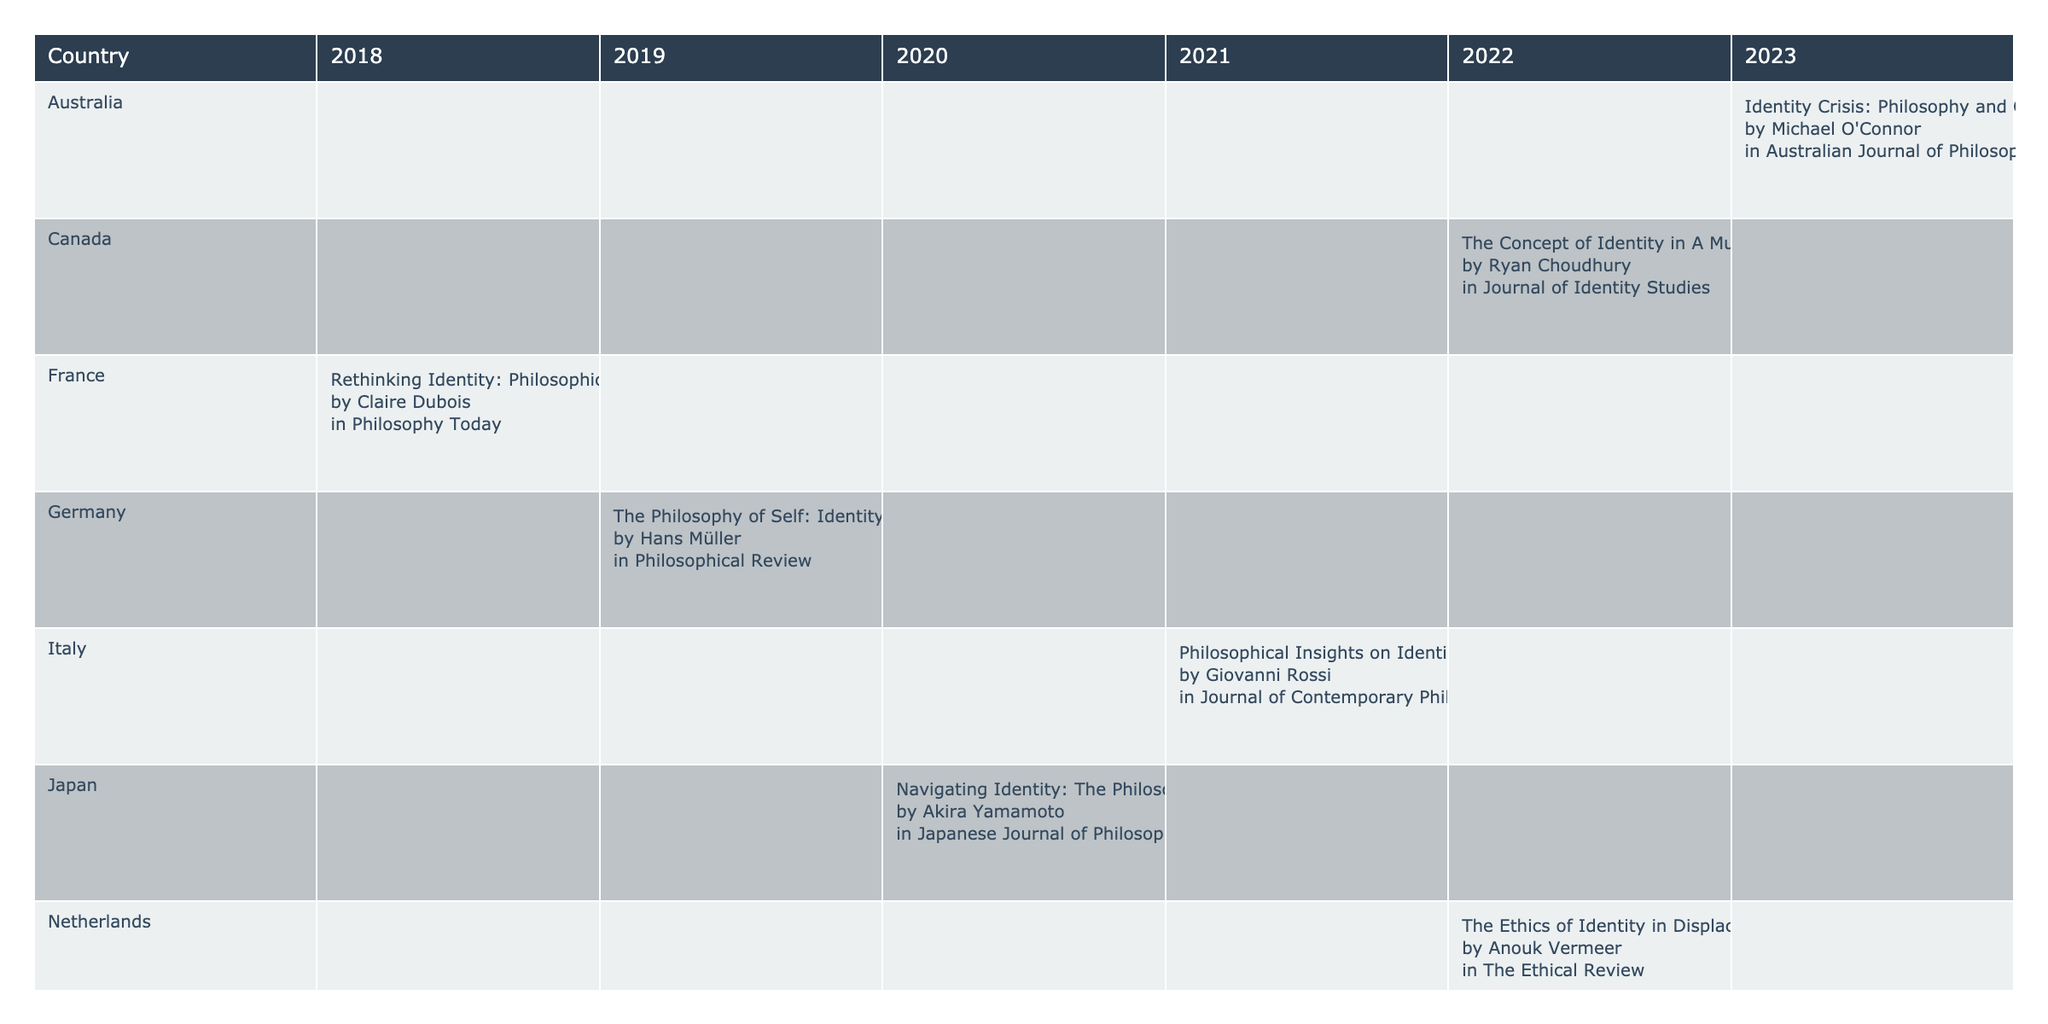What is the title of the publication from Germany? Looking at the row for Germany, the publication title for the year 2019 is "The Philosophy of Self: Identity in the Age of Migration".
Answer: The Philosophy of Self: Identity in the Age of Migration How many publications are listed for the year 2022? By counting the entries in the year 2022, there are two publications: one from Canada and one from the Netherlands.
Answer: 2 Is there a publication from South Africa in 2020? Checking the table, South Africa has a publication listed in 2019, but there is no entry for the year 2020.
Answer: No Which country had the earliest publication related to identity and displacement? The earliest year in the table is 2018, and the only entry is from France with the title "Rethinking Identity: Philosophical Approaches to Displacement".
Answer: France What is the average number of publications per year based on the data provided? There are a total of 10 publications across the years 2018 to 2023 (6 years). The average is thus 10 publications divided by 6 years, which equals approximately 1.67.
Answer: 1.67 How many different authors contributed to publications in 2021? In 2021, there are two publications listed: one from the United Kingdom by Sarah Thompson and another from Italy by Giovanni Rossi. Thus, there are two different authors.
Answer: 2 Which publication has "Cultural Displacement" in the title? By scanning through the titles, the publication "Identity Crisis: Philosophy and Cultural Displacement" from Australia in 2023 contains "Cultural Displacement".
Answer: Identity Crisis: Philosophy and Cultural Displacement Was there a publication from Japan focused on identity in the same year as any from the United States? The United States has a publication in 2020 and Japan also has a publication titled "Navigating Identity: The Philosophy of Belonging in Displacement" in the same year.
Answer: Yes What is the latest year that has publications based on the data? The latest year presented in the table is 2023, with a publication from Australia.
Answer: 2023 Which country has the most recent publication on identity, according to the table? The publication from Australia in 2023 is the most recent entry regarding identity, making Australia the country with the latest publication.
Answer: Australia 